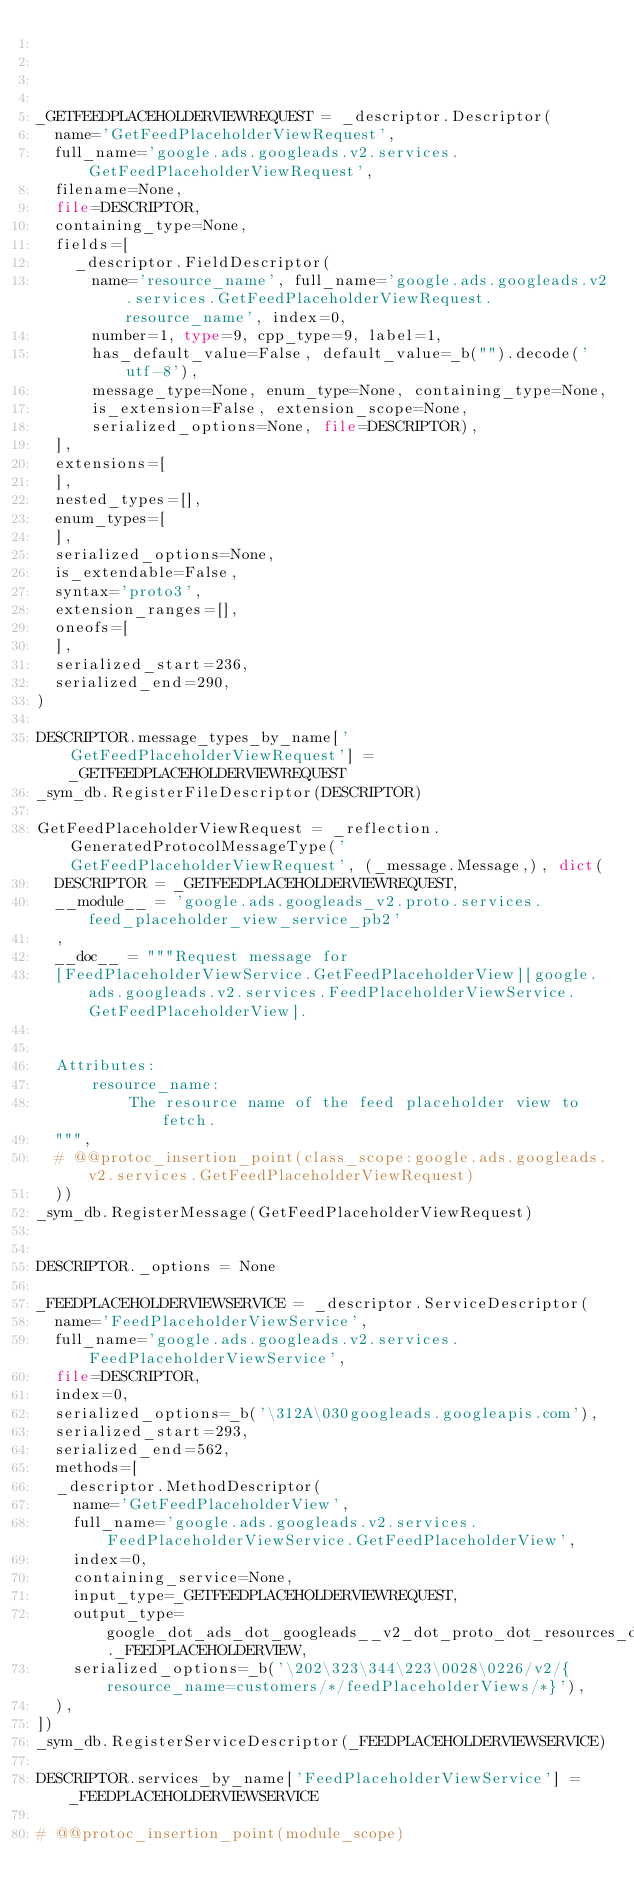Convert code to text. <code><loc_0><loc_0><loc_500><loc_500><_Python_>



_GETFEEDPLACEHOLDERVIEWREQUEST = _descriptor.Descriptor(
  name='GetFeedPlaceholderViewRequest',
  full_name='google.ads.googleads.v2.services.GetFeedPlaceholderViewRequest',
  filename=None,
  file=DESCRIPTOR,
  containing_type=None,
  fields=[
    _descriptor.FieldDescriptor(
      name='resource_name', full_name='google.ads.googleads.v2.services.GetFeedPlaceholderViewRequest.resource_name', index=0,
      number=1, type=9, cpp_type=9, label=1,
      has_default_value=False, default_value=_b("").decode('utf-8'),
      message_type=None, enum_type=None, containing_type=None,
      is_extension=False, extension_scope=None,
      serialized_options=None, file=DESCRIPTOR),
  ],
  extensions=[
  ],
  nested_types=[],
  enum_types=[
  ],
  serialized_options=None,
  is_extendable=False,
  syntax='proto3',
  extension_ranges=[],
  oneofs=[
  ],
  serialized_start=236,
  serialized_end=290,
)

DESCRIPTOR.message_types_by_name['GetFeedPlaceholderViewRequest'] = _GETFEEDPLACEHOLDERVIEWREQUEST
_sym_db.RegisterFileDescriptor(DESCRIPTOR)

GetFeedPlaceholderViewRequest = _reflection.GeneratedProtocolMessageType('GetFeedPlaceholderViewRequest', (_message.Message,), dict(
  DESCRIPTOR = _GETFEEDPLACEHOLDERVIEWREQUEST,
  __module__ = 'google.ads.googleads_v2.proto.services.feed_placeholder_view_service_pb2'
  ,
  __doc__ = """Request message for
  [FeedPlaceholderViewService.GetFeedPlaceholderView][google.ads.googleads.v2.services.FeedPlaceholderViewService.GetFeedPlaceholderView].
  
  
  Attributes:
      resource_name:
          The resource name of the feed placeholder view to fetch.
  """,
  # @@protoc_insertion_point(class_scope:google.ads.googleads.v2.services.GetFeedPlaceholderViewRequest)
  ))
_sym_db.RegisterMessage(GetFeedPlaceholderViewRequest)


DESCRIPTOR._options = None

_FEEDPLACEHOLDERVIEWSERVICE = _descriptor.ServiceDescriptor(
  name='FeedPlaceholderViewService',
  full_name='google.ads.googleads.v2.services.FeedPlaceholderViewService',
  file=DESCRIPTOR,
  index=0,
  serialized_options=_b('\312A\030googleads.googleapis.com'),
  serialized_start=293,
  serialized_end=562,
  methods=[
  _descriptor.MethodDescriptor(
    name='GetFeedPlaceholderView',
    full_name='google.ads.googleads.v2.services.FeedPlaceholderViewService.GetFeedPlaceholderView',
    index=0,
    containing_service=None,
    input_type=_GETFEEDPLACEHOLDERVIEWREQUEST,
    output_type=google_dot_ads_dot_googleads__v2_dot_proto_dot_resources_dot_feed__placeholder__view__pb2._FEEDPLACEHOLDERVIEW,
    serialized_options=_b('\202\323\344\223\0028\0226/v2/{resource_name=customers/*/feedPlaceholderViews/*}'),
  ),
])
_sym_db.RegisterServiceDescriptor(_FEEDPLACEHOLDERVIEWSERVICE)

DESCRIPTOR.services_by_name['FeedPlaceholderViewService'] = _FEEDPLACEHOLDERVIEWSERVICE

# @@protoc_insertion_point(module_scope)
</code> 